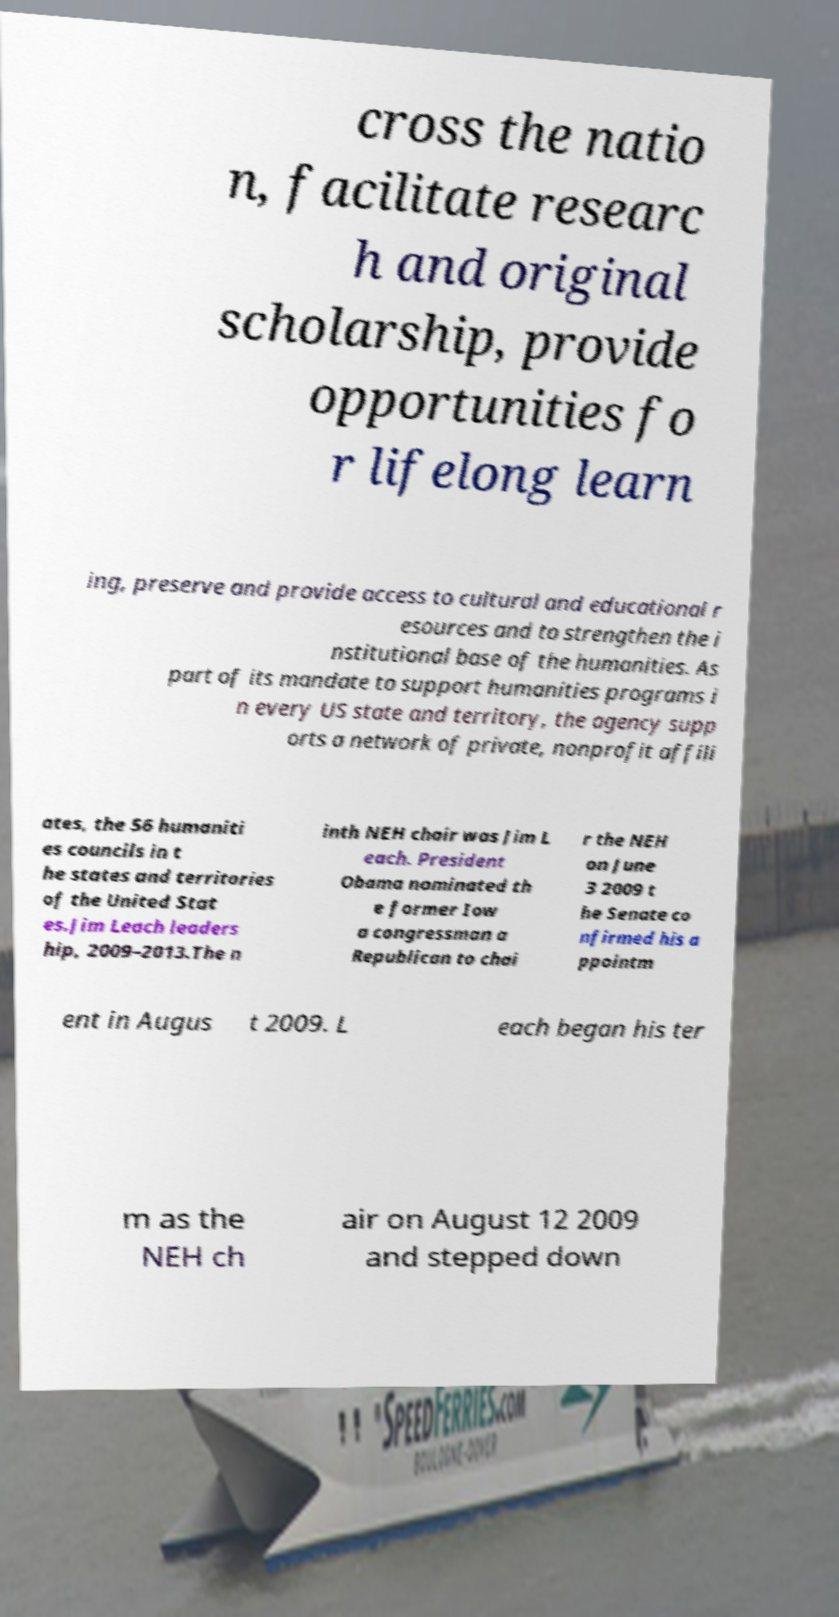I need the written content from this picture converted into text. Can you do that? cross the natio n, facilitate researc h and original scholarship, provide opportunities fo r lifelong learn ing, preserve and provide access to cultural and educational r esources and to strengthen the i nstitutional base of the humanities. As part of its mandate to support humanities programs i n every US state and territory, the agency supp orts a network of private, nonprofit affili ates, the 56 humaniti es councils in t he states and territories of the United Stat es.Jim Leach leaders hip, 2009–2013.The n inth NEH chair was Jim L each. President Obama nominated th e former Iow a congressman a Republican to chai r the NEH on June 3 2009 t he Senate co nfirmed his a ppointm ent in Augus t 2009. L each began his ter m as the NEH ch air on August 12 2009 and stepped down 